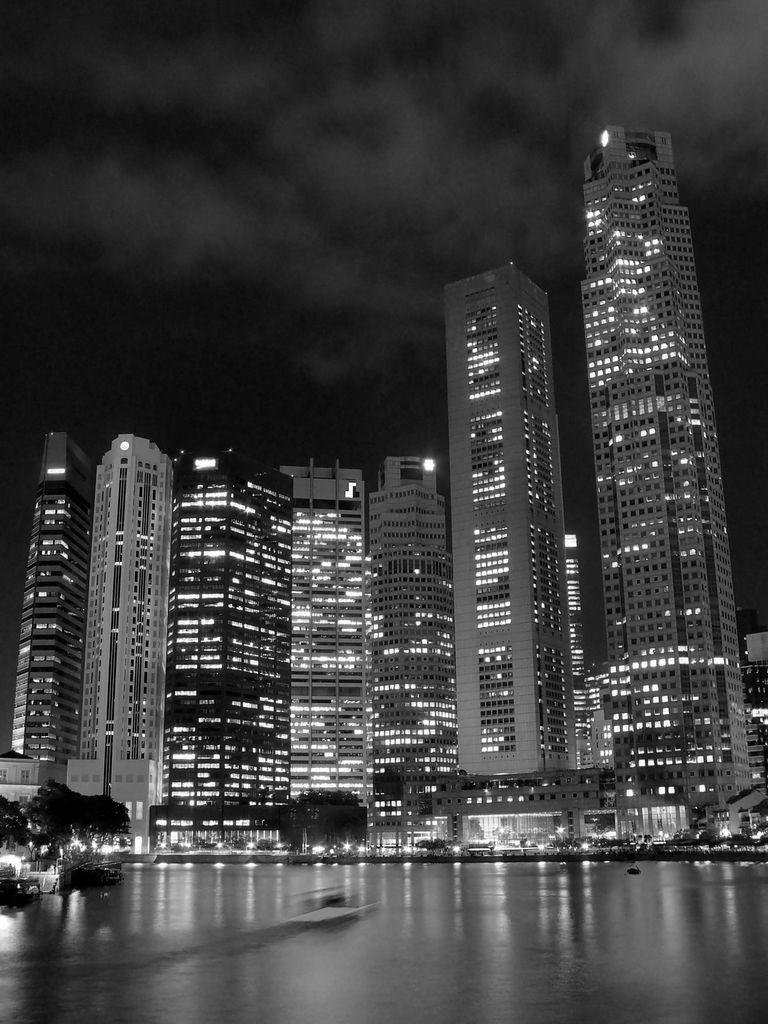What type of structures are present in the image? There are big buildings in the image. What feature do the buildings have? The buildings have lights. What part of the natural environment is visible in the image? The sky is visible at the top of the image. What is the time of day depicted in the image? The sky is night sky, indicating that it is nighttime in the image. What type of sheet is covering the writer in the image? There is no writer or sheet present in the image; it features big buildings with lights and a night sky. 